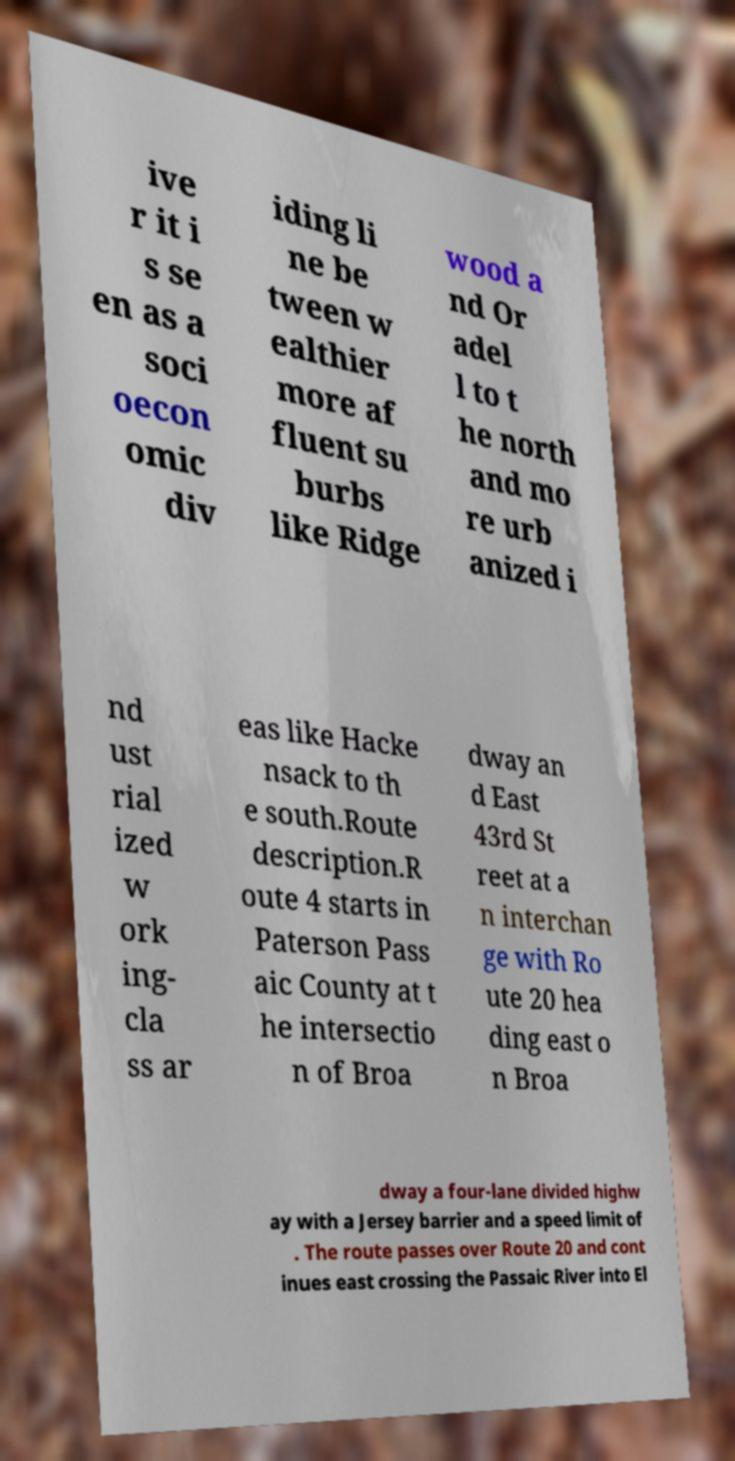Could you assist in decoding the text presented in this image and type it out clearly? ive r it i s se en as a soci oecon omic div iding li ne be tween w ealthier more af fluent su burbs like Ridge wood a nd Or adel l to t he north and mo re urb anized i nd ust rial ized w ork ing- cla ss ar eas like Hacke nsack to th e south.Route description.R oute 4 starts in Paterson Pass aic County at t he intersectio n of Broa dway an d East 43rd St reet at a n interchan ge with Ro ute 20 hea ding east o n Broa dway a four-lane divided highw ay with a Jersey barrier and a speed limit of . The route passes over Route 20 and cont inues east crossing the Passaic River into El 